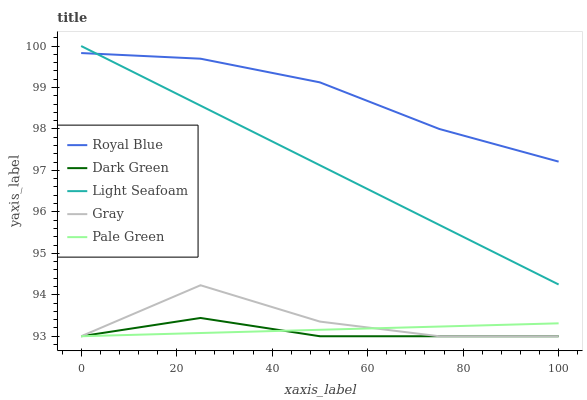Does Dark Green have the minimum area under the curve?
Answer yes or no. Yes. Does Royal Blue have the maximum area under the curve?
Answer yes or no. Yes. Does Gray have the minimum area under the curve?
Answer yes or no. No. Does Gray have the maximum area under the curve?
Answer yes or no. No. Is Light Seafoam the smoothest?
Answer yes or no. Yes. Is Gray the roughest?
Answer yes or no. Yes. Is Gray the smoothest?
Answer yes or no. No. Is Light Seafoam the roughest?
Answer yes or no. No. Does Light Seafoam have the lowest value?
Answer yes or no. No. Does Gray have the highest value?
Answer yes or no. No. Is Pale Green less than Royal Blue?
Answer yes or no. Yes. Is Light Seafoam greater than Pale Green?
Answer yes or no. Yes. Does Pale Green intersect Royal Blue?
Answer yes or no. No. 